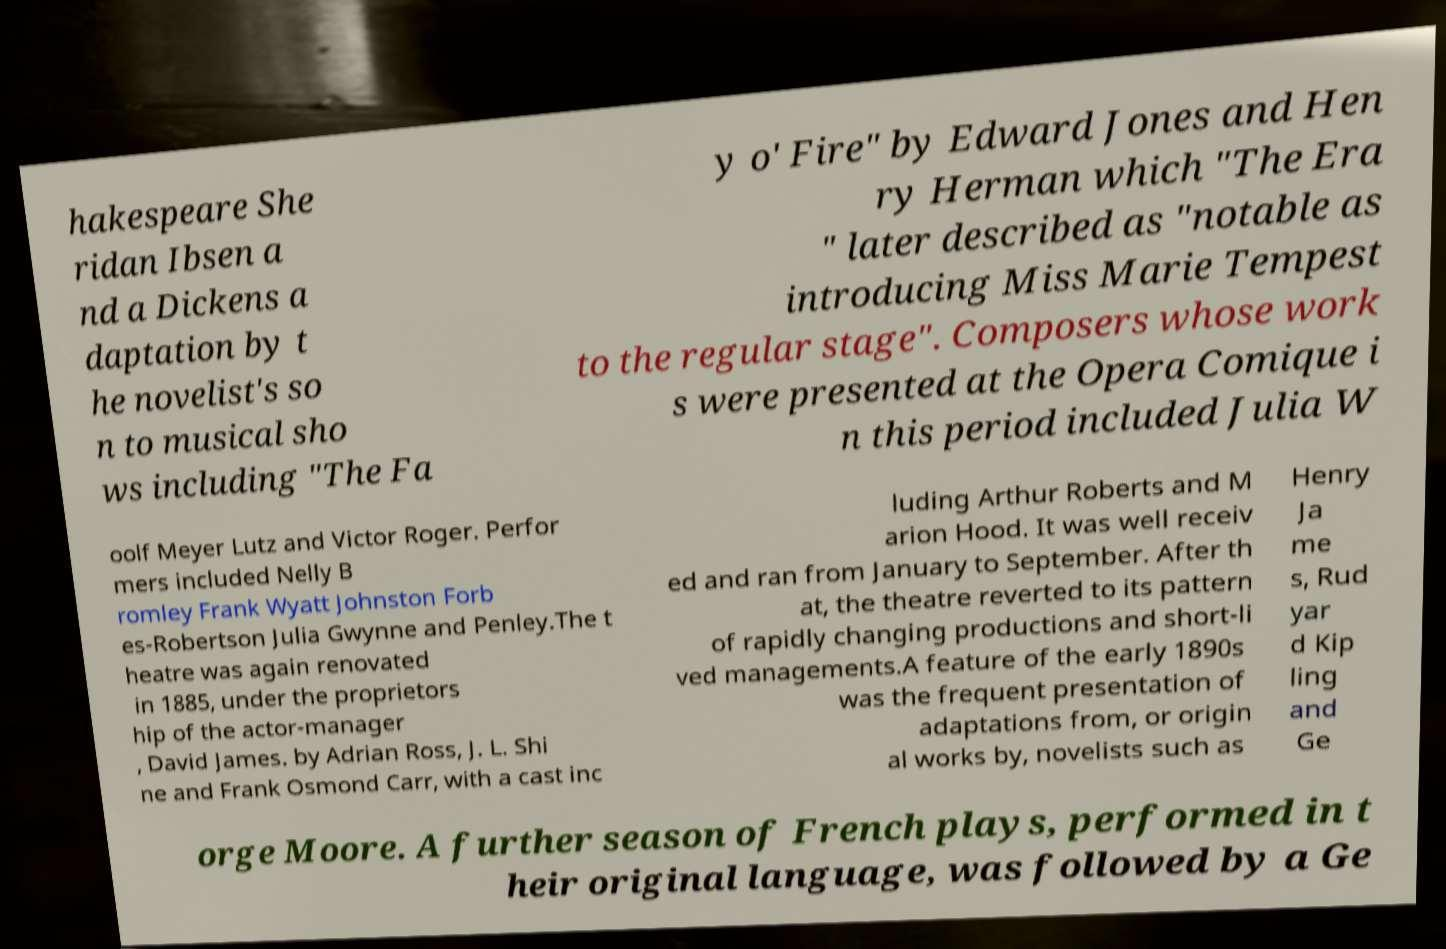Can you read and provide the text displayed in the image?This photo seems to have some interesting text. Can you extract and type it out for me? hakespeare She ridan Ibsen a nd a Dickens a daptation by t he novelist's so n to musical sho ws including "The Fa y o' Fire" by Edward Jones and Hen ry Herman which "The Era " later described as "notable as introducing Miss Marie Tempest to the regular stage". Composers whose work s were presented at the Opera Comique i n this period included Julia W oolf Meyer Lutz and Victor Roger. Perfor mers included Nelly B romley Frank Wyatt Johnston Forb es-Robertson Julia Gwynne and Penley.The t heatre was again renovated in 1885, under the proprietors hip of the actor-manager , David James. by Adrian Ross, J. L. Shi ne and Frank Osmond Carr, with a cast inc luding Arthur Roberts and M arion Hood. It was well receiv ed and ran from January to September. After th at, the theatre reverted to its pattern of rapidly changing productions and short-li ved managements.A feature of the early 1890s was the frequent presentation of adaptations from, or origin al works by, novelists such as Henry Ja me s, Rud yar d Kip ling and Ge orge Moore. A further season of French plays, performed in t heir original language, was followed by a Ge 